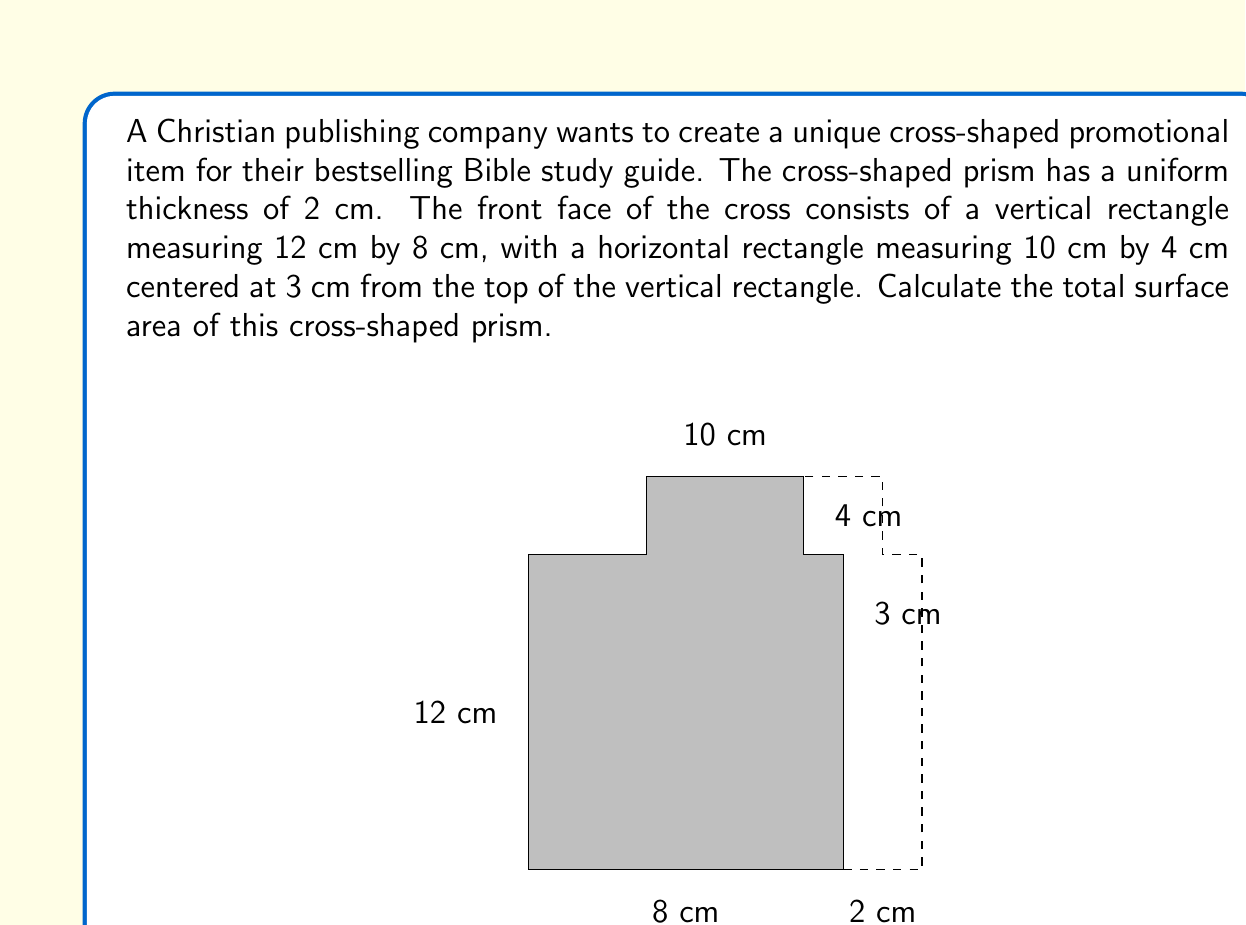Help me with this question. To find the surface area of the cross-shaped prism, we need to calculate the areas of all faces and sum them up. Let's break it down step by step:

1. Front and back faces:
   The area of the cross shape can be calculated by adding the areas of the two rectangles and subtracting the overlap.
   $$A_{front} = (12 \times 8) + (10 \times 4) - (4 \times 2) = 96 + 40 - 8 = 128 \text{ cm}^2$$
   There are two identical faces (front and back), so the total area is:
   $$A_{front\_and\_back} = 2 \times 128 = 256 \text{ cm}^2$$

2. Side faces:
   There are six rectangular side faces. Let's calculate their areas:
   - Two vertical long sides: $2 \times (12 \times 2) = 48 \text{ cm}^2$
   - Two horizontal long sides: $2 \times (10 \times 2) = 40 \text{ cm}^2$
   - Two vertical short sides: $2 \times (4 \times 2) = 16 \text{ cm}^2$
   
   Total area of side faces:
   $$A_{sides} = 48 + 40 + 16 = 104 \text{ cm}^2$$

3. Total surface area:
   Sum up all the face areas:
   $$A_{total} = A_{front\_and\_back} + A_{sides} = 256 + 104 = 360 \text{ cm}^2$$

Therefore, the total surface area of the cross-shaped prism is 360 cm².
Answer: $360 \text{ cm}^2$ 